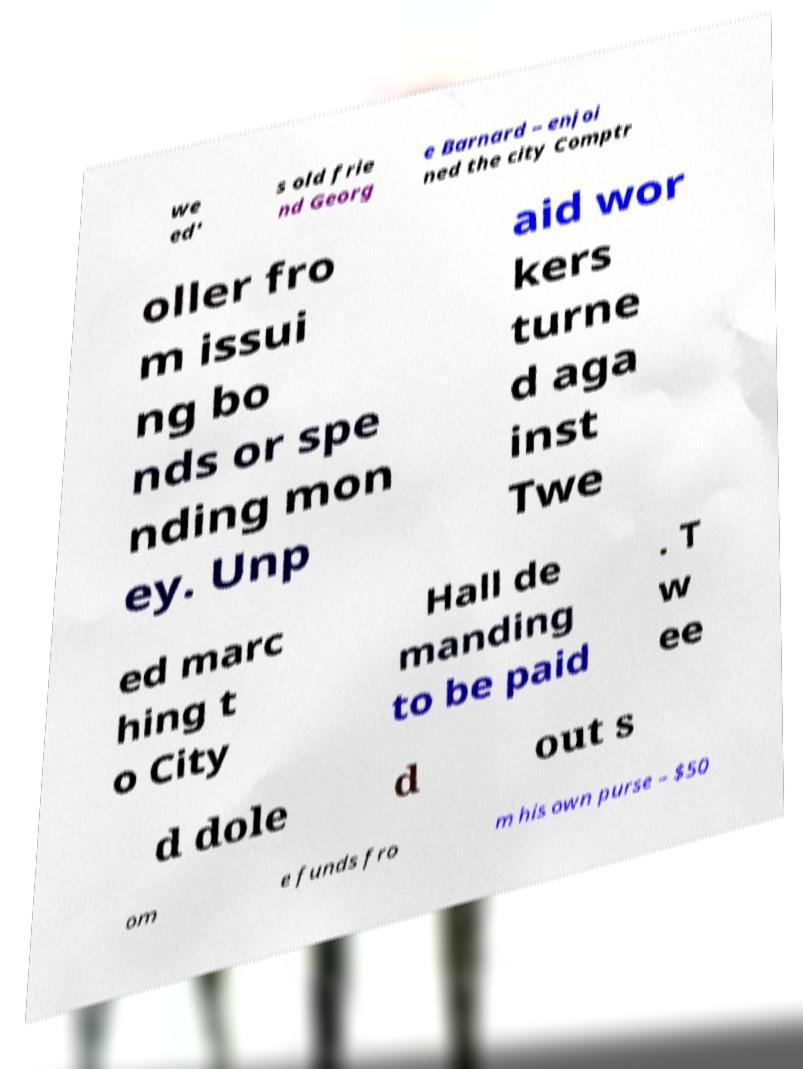Can you read and provide the text displayed in the image?This photo seems to have some interesting text. Can you extract and type it out for me? we ed' s old frie nd Georg e Barnard – enjoi ned the city Comptr oller fro m issui ng bo nds or spe nding mon ey. Unp aid wor kers turne d aga inst Twe ed marc hing t o City Hall de manding to be paid . T w ee d dole d out s om e funds fro m his own purse – $50 